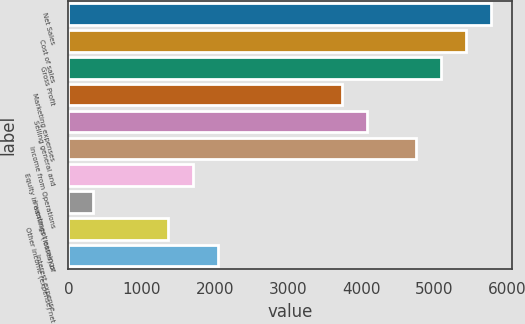Convert chart. <chart><loc_0><loc_0><loc_500><loc_500><bar_chart><fcel>Net Sales<fcel>Cost of sales<fcel>Gross Profit<fcel>Marketing expenses<fcel>Selling general and<fcel>Income from Operations<fcel>Equity in earnings (losses) of<fcel>Investment earnings<fcel>Other income (expense) net<fcel>Interest expense<nl><fcel>5770.64<fcel>5431.23<fcel>5091.82<fcel>3734.18<fcel>4073.59<fcel>4752.41<fcel>1697.72<fcel>340.08<fcel>1358.31<fcel>2037.13<nl></chart> 